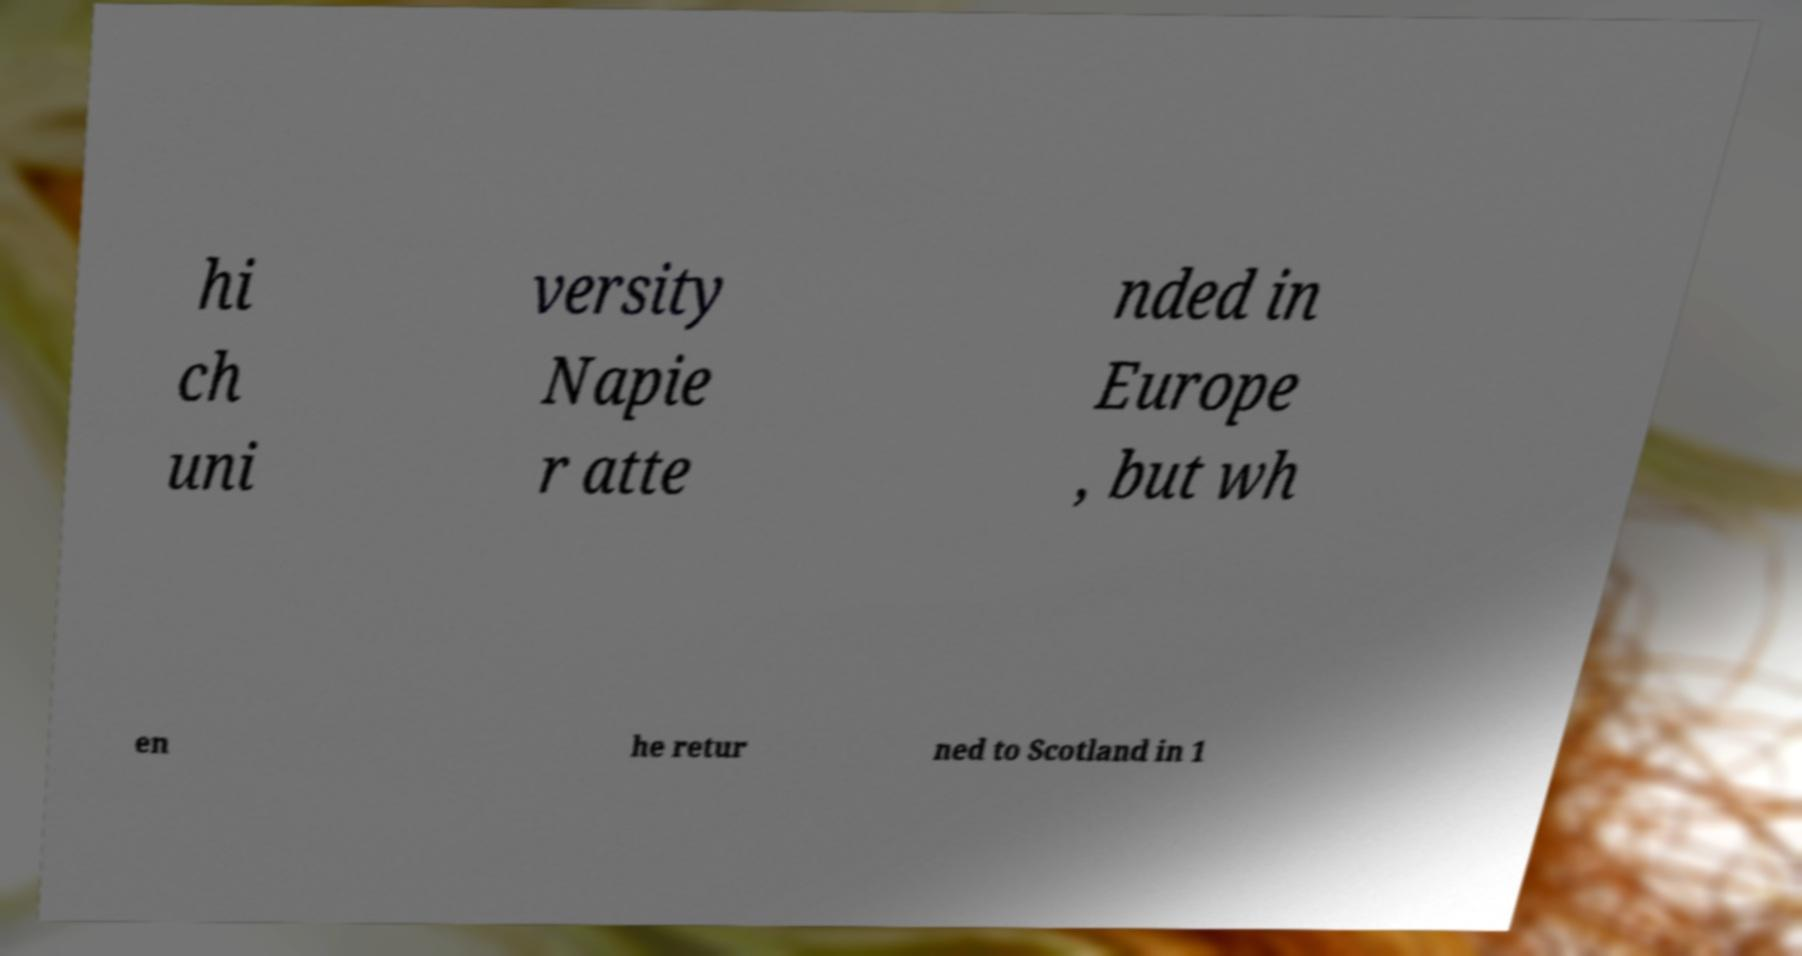Please read and relay the text visible in this image. What does it say? hi ch uni versity Napie r atte nded in Europe , but wh en he retur ned to Scotland in 1 